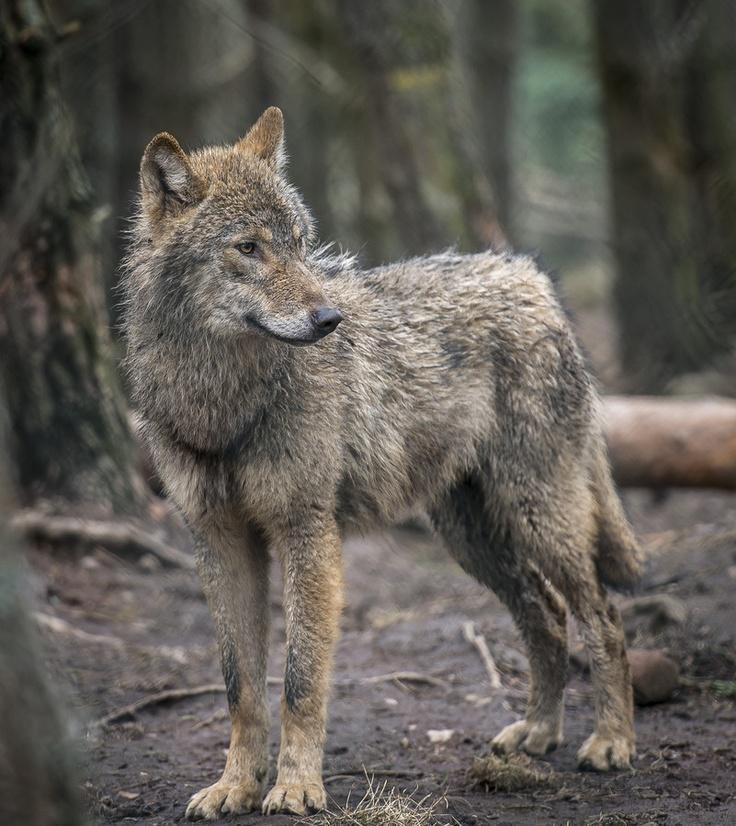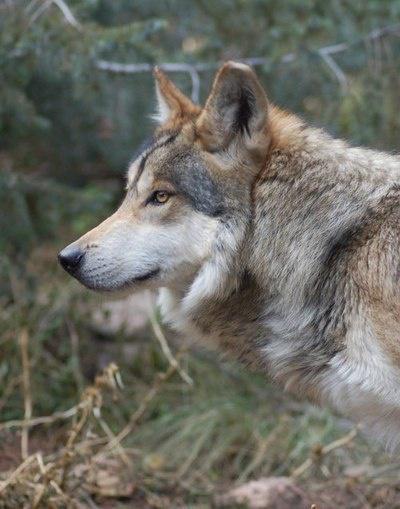The first image is the image on the left, the second image is the image on the right. Analyze the images presented: Is the assertion "One image contains more than one wolf, and one image contains a single wolf, who is standing on all fours." valid? Answer yes or no. No. 